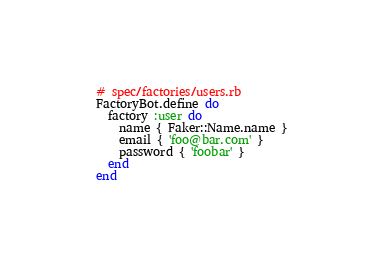Convert code to text. <code><loc_0><loc_0><loc_500><loc_500><_Ruby_># spec/factories/users.rb
FactoryBot.define do
  factory :user do
    name { Faker::Name.name }
    email { 'foo@bar.com' }
    password { 'foobar' }
  end
end
</code> 